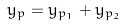<formula> <loc_0><loc_0><loc_500><loc_500>y _ { p } = y _ { p _ { 1 } } + y _ { p _ { 2 } }</formula> 